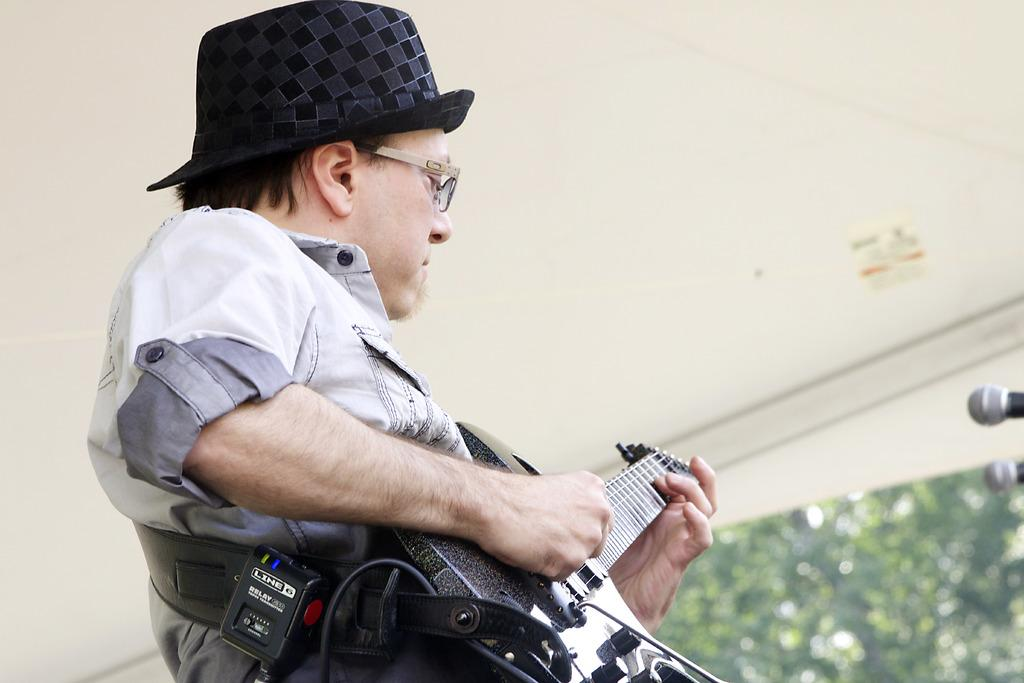How many people are in the image? There are three people in the image. What is one of the people doing in the image? One of the people is holding a guitar. What color is the eye of the person holding the guitar in the image? There is no eye visible in the image, as the person holding the guitar is not shown from a close enough perspective to see their eyes. 